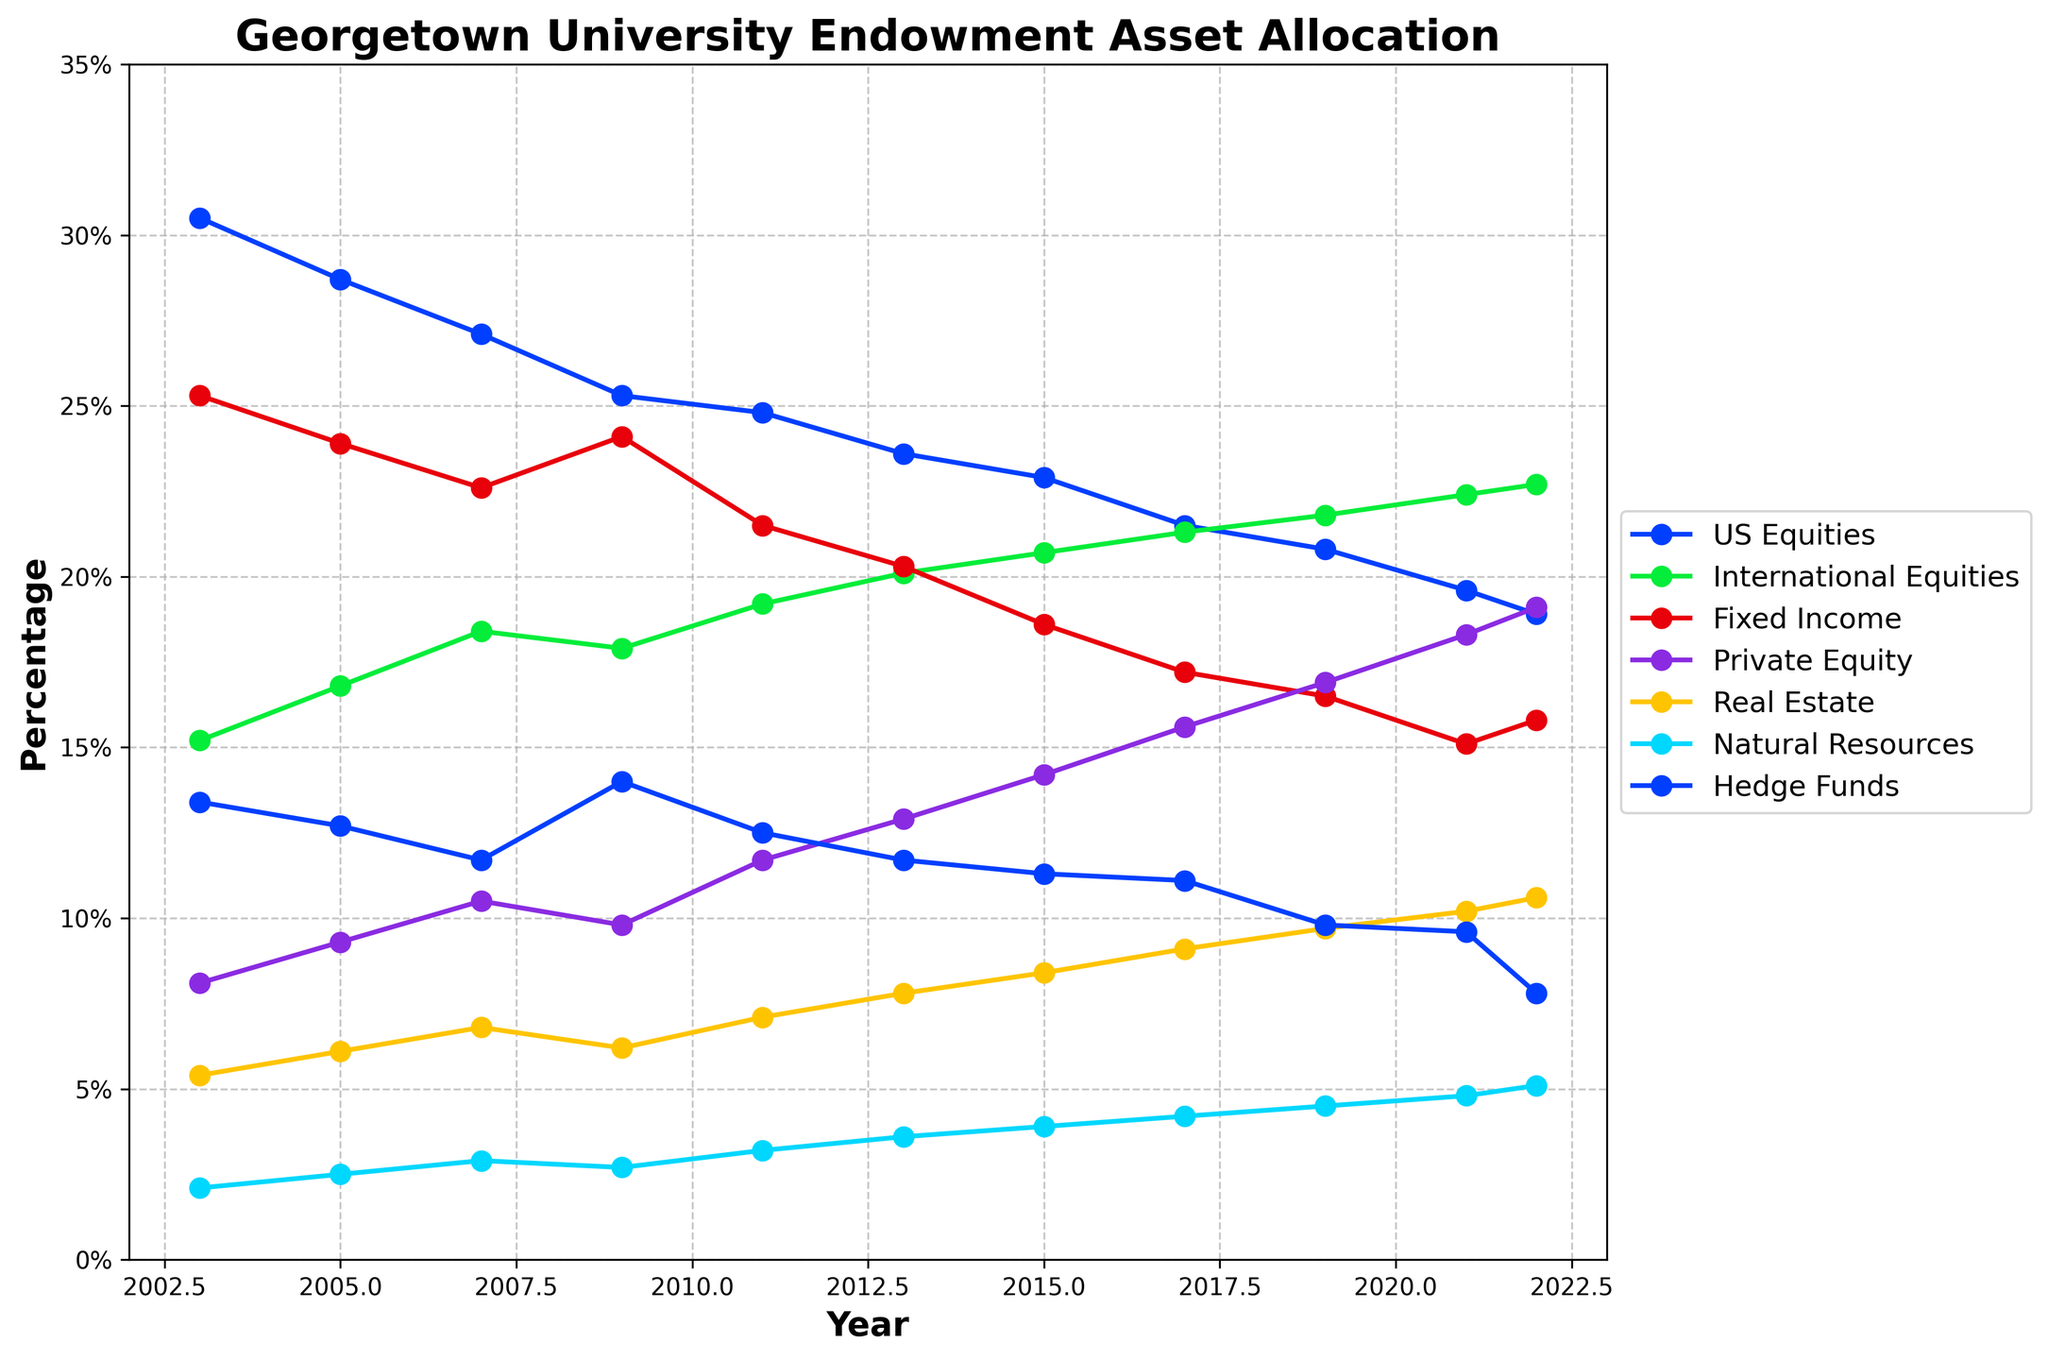what is the trend of the "Total Endowment Value" over the years? The "Total Endowment Value" shows an overall increasing trend from 2003 to 2022, starting around 0.745 billion in 2003, reaching a peak of about 2.412 billion in 2021, and then slightly decreasing to 2.178 billion in 2022
Answer: Increasing trend How did the allocation of US Equities change from 2003 to 2022? The allocation of US Equities decreased from 30.5% in 2003 to 18.9% in 2022. This is observed by comparing the percentage values in the respective years.
Answer: Decreased Which asset class had the highest percentage allocation in 2021? In 2021, the asset class with the highest percentage allocation was Private Equity, at 18.3%
Answer: Private Equity What is the average allocation for Real Estate from 2003 to 2022? The allocation values for Real Estate are: 5.4%, 6.1%, 6.8%, 6.2%, 7.1%, 7.8%, 8.4%, 9.1%, 9.7%, 10.2%, and 10.6%. Average = (5.4% + 6.1% + 6.8% + 6.2% + 7.1% + 7.8% + 8.4% + 9.1% + 9.7% + 10.2% + 10.6%) / 11 ≈ 7.74%
Answer: ~7.74% Which year experienced the largest drop in 'Total Endowment Value'? Comparing the values, the largest drop was from 1.059 billion in 2007 to 0.795 billion in 2009.
Answer: 2007 to 2009 What patterns do you see in the allocation of Hedge Funds over the years? The allocation for Hedge Funds shows a decreasing trend from 13.4% in 2003 to 7.8% in 2022, with intermediate fluctuations.
Answer: Decreasing trend Which two asset classes had increasing allocations from 2003 to 2022? Private Equity and Real Estate had increasing allocations. Private Equity increased from 8.1% to 19.1%, and Real Estate increased from 5.4% to 10.6%.
Answer: Private Equity and Real Estate By how much did the allocation for Natural Resources increase from 2003 to 2022? The allocation for Natural Resources increased from 2.1% in 2003 to 5.1% in 2022. Increase = 5.1% - 2.1% = 3%
Answer: 3% What years show a decline in the 'Total Endowment Value'? The years showing declines are between 2007-2009 and 2021-2022. These are derived by comparing the total endowment values in consecutive years, where values decreases are observed.
Answer: 2007-2009, 2021-2022 